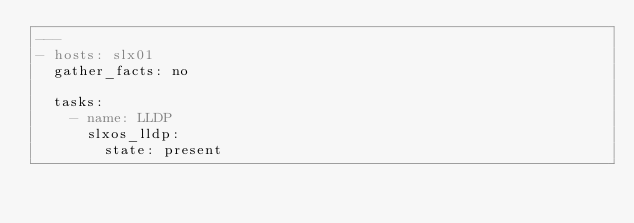Convert code to text. <code><loc_0><loc_0><loc_500><loc_500><_YAML_>---
- hosts: slx01
  gather_facts: no

  tasks:
    - name: LLDP
      slxos_lldp:
        state: present
</code> 